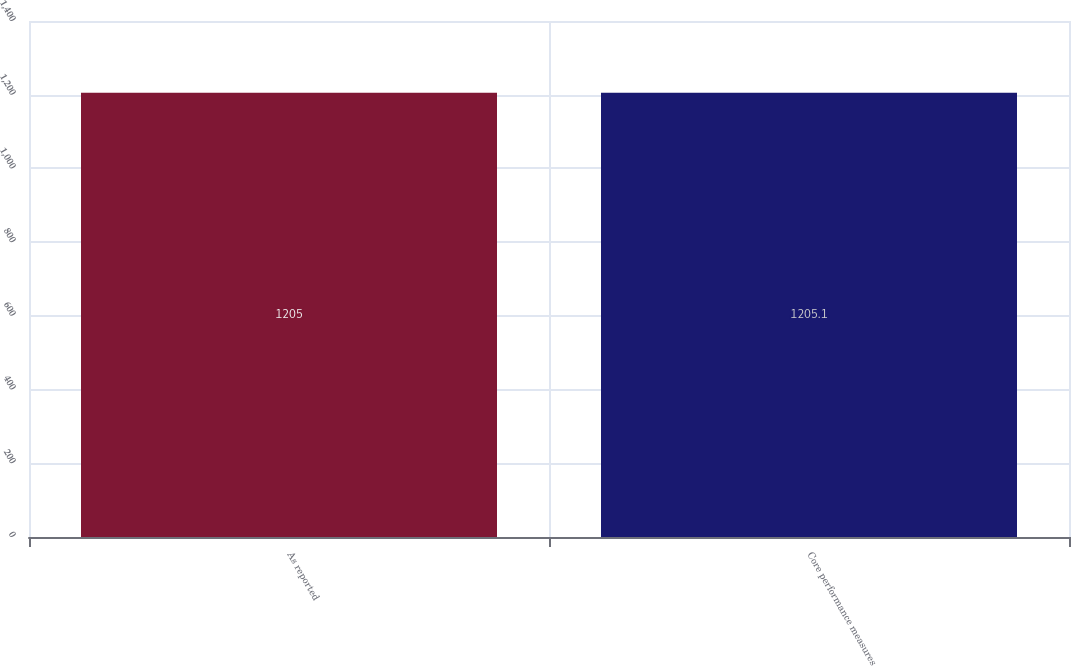Convert chart to OTSL. <chart><loc_0><loc_0><loc_500><loc_500><bar_chart><fcel>As reported<fcel>Core performance measures<nl><fcel>1205<fcel>1205.1<nl></chart> 